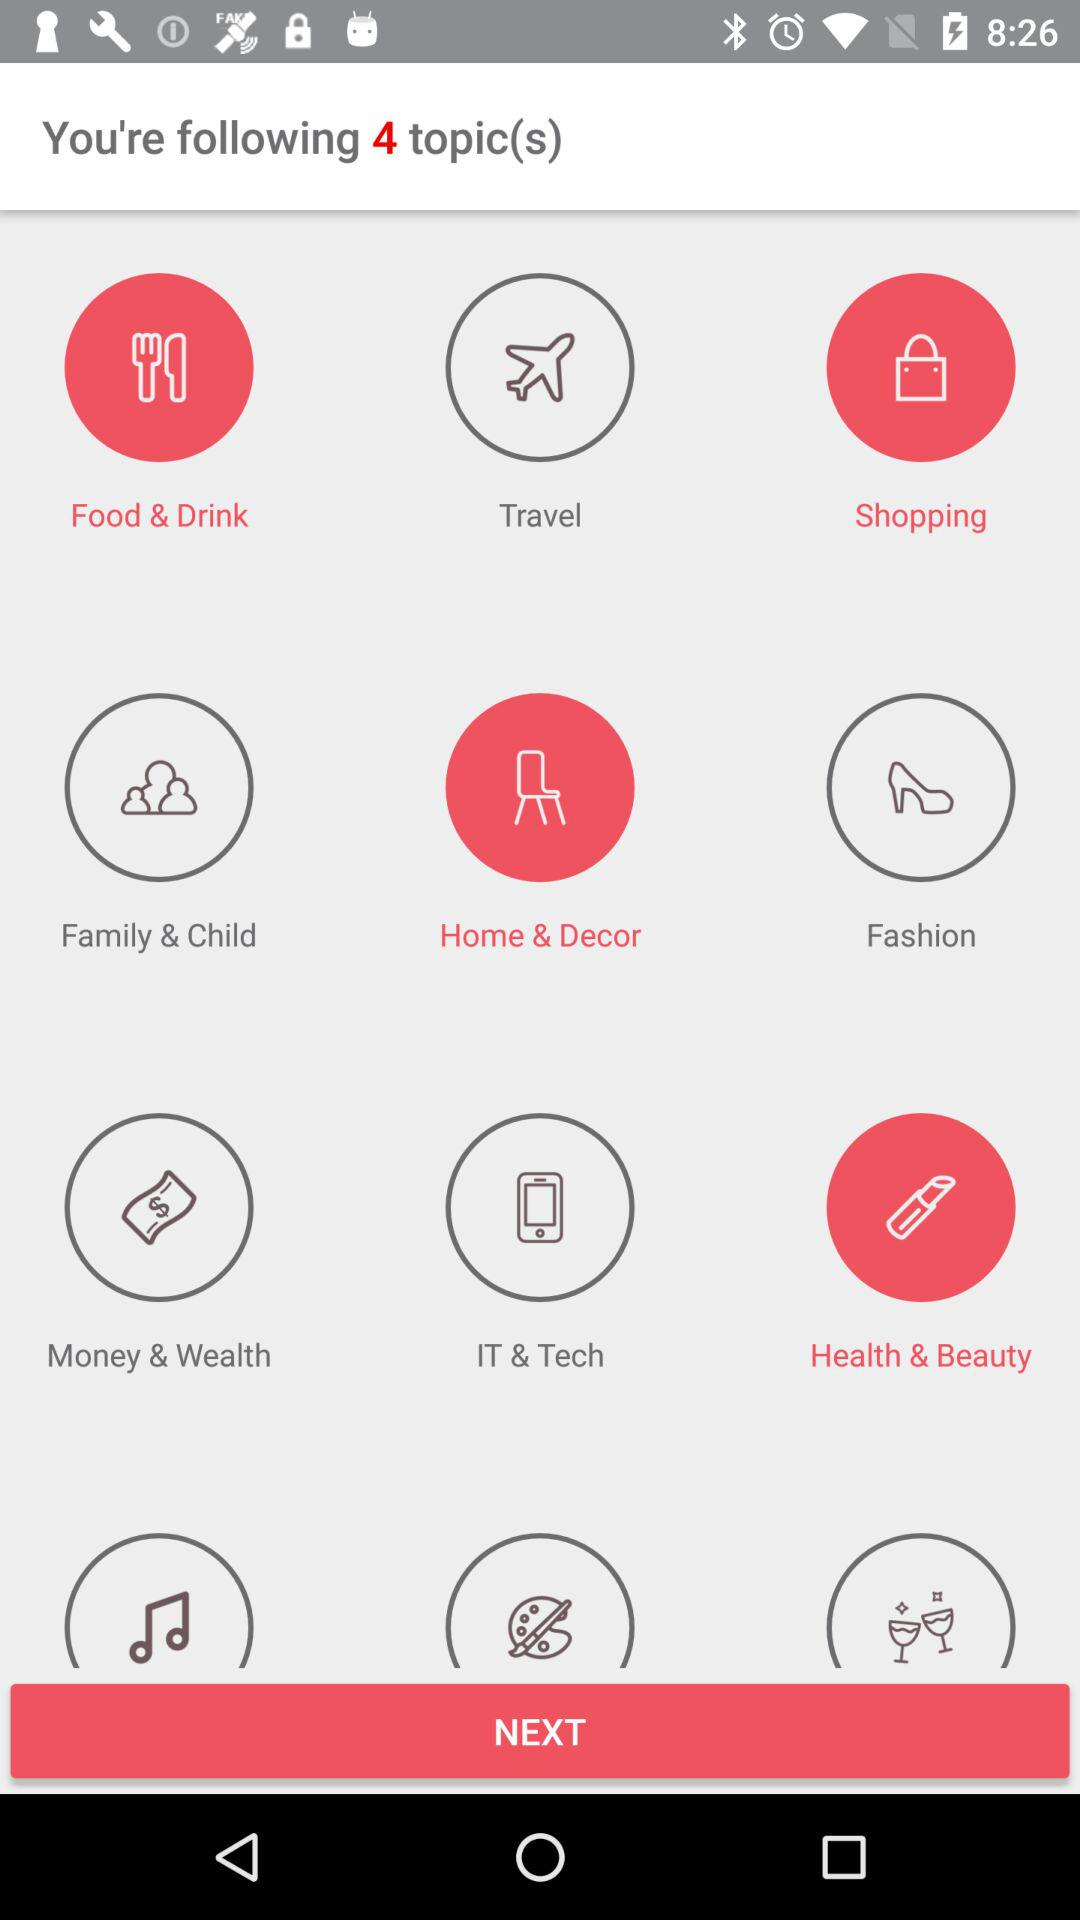How many total topics is the person following? The total number of topics that the person is following is 4. 